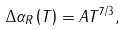<formula> <loc_0><loc_0><loc_500><loc_500>\Delta \alpha _ { R } \left ( T \right ) = A T ^ { 7 / 3 } ,</formula> 